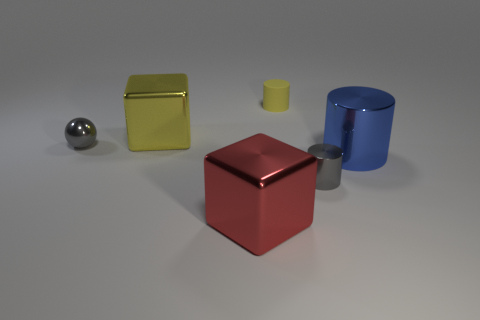Add 3 large blue things. How many objects exist? 9 Subtract all balls. How many objects are left? 5 Add 4 tiny purple metal balls. How many tiny purple metal balls exist? 4 Subtract 1 yellow blocks. How many objects are left? 5 Subtract all tiny purple metal cubes. Subtract all tiny yellow matte cylinders. How many objects are left? 5 Add 1 small rubber cylinders. How many small rubber cylinders are left? 2 